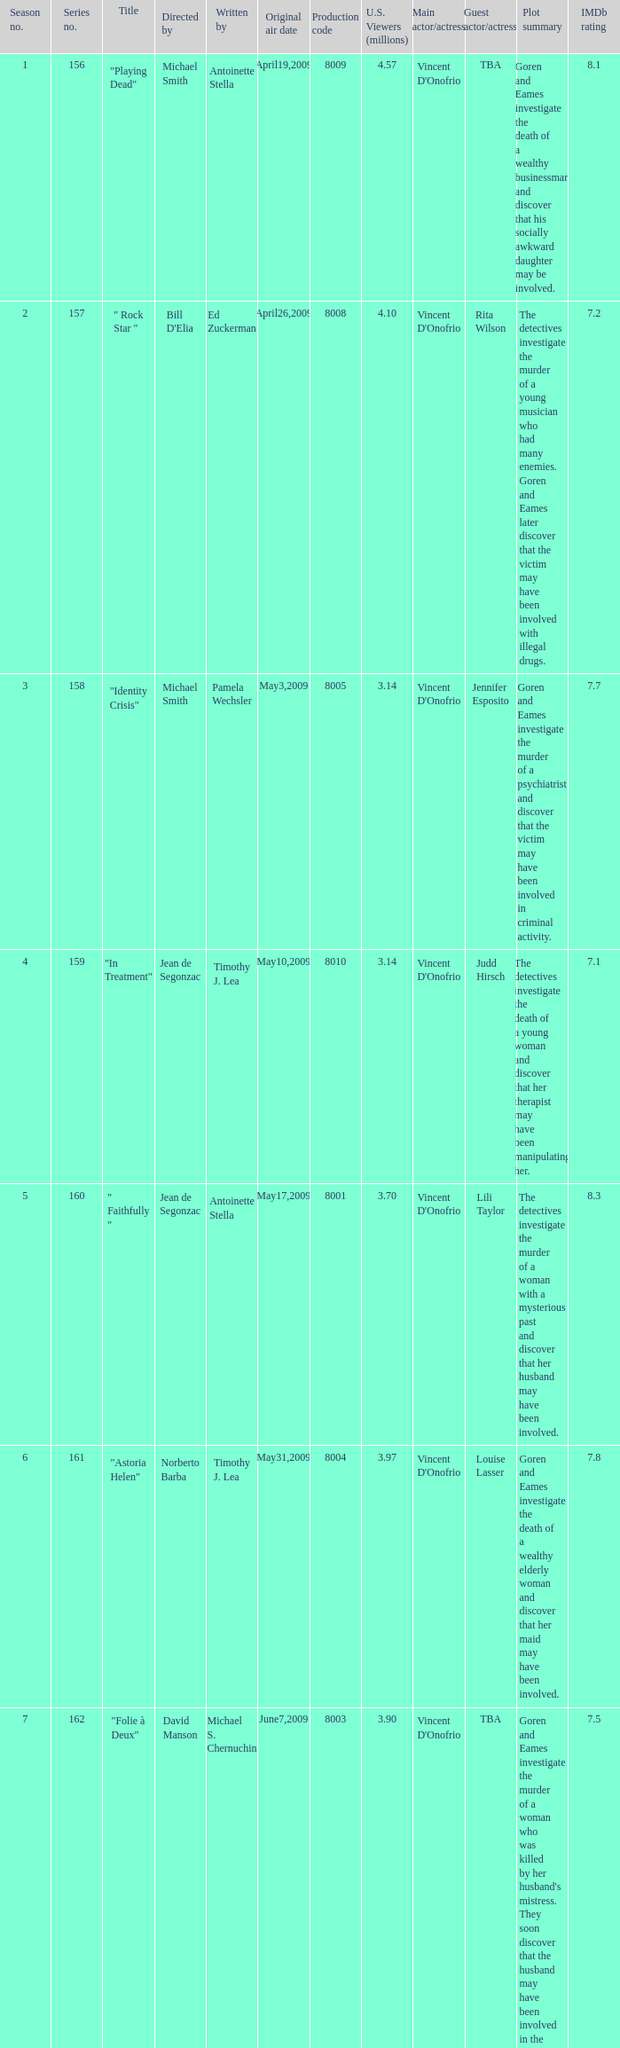What is the name of the episode whose writer is timothy j. lea and the director is norberto barba? "Astoria Helen". 